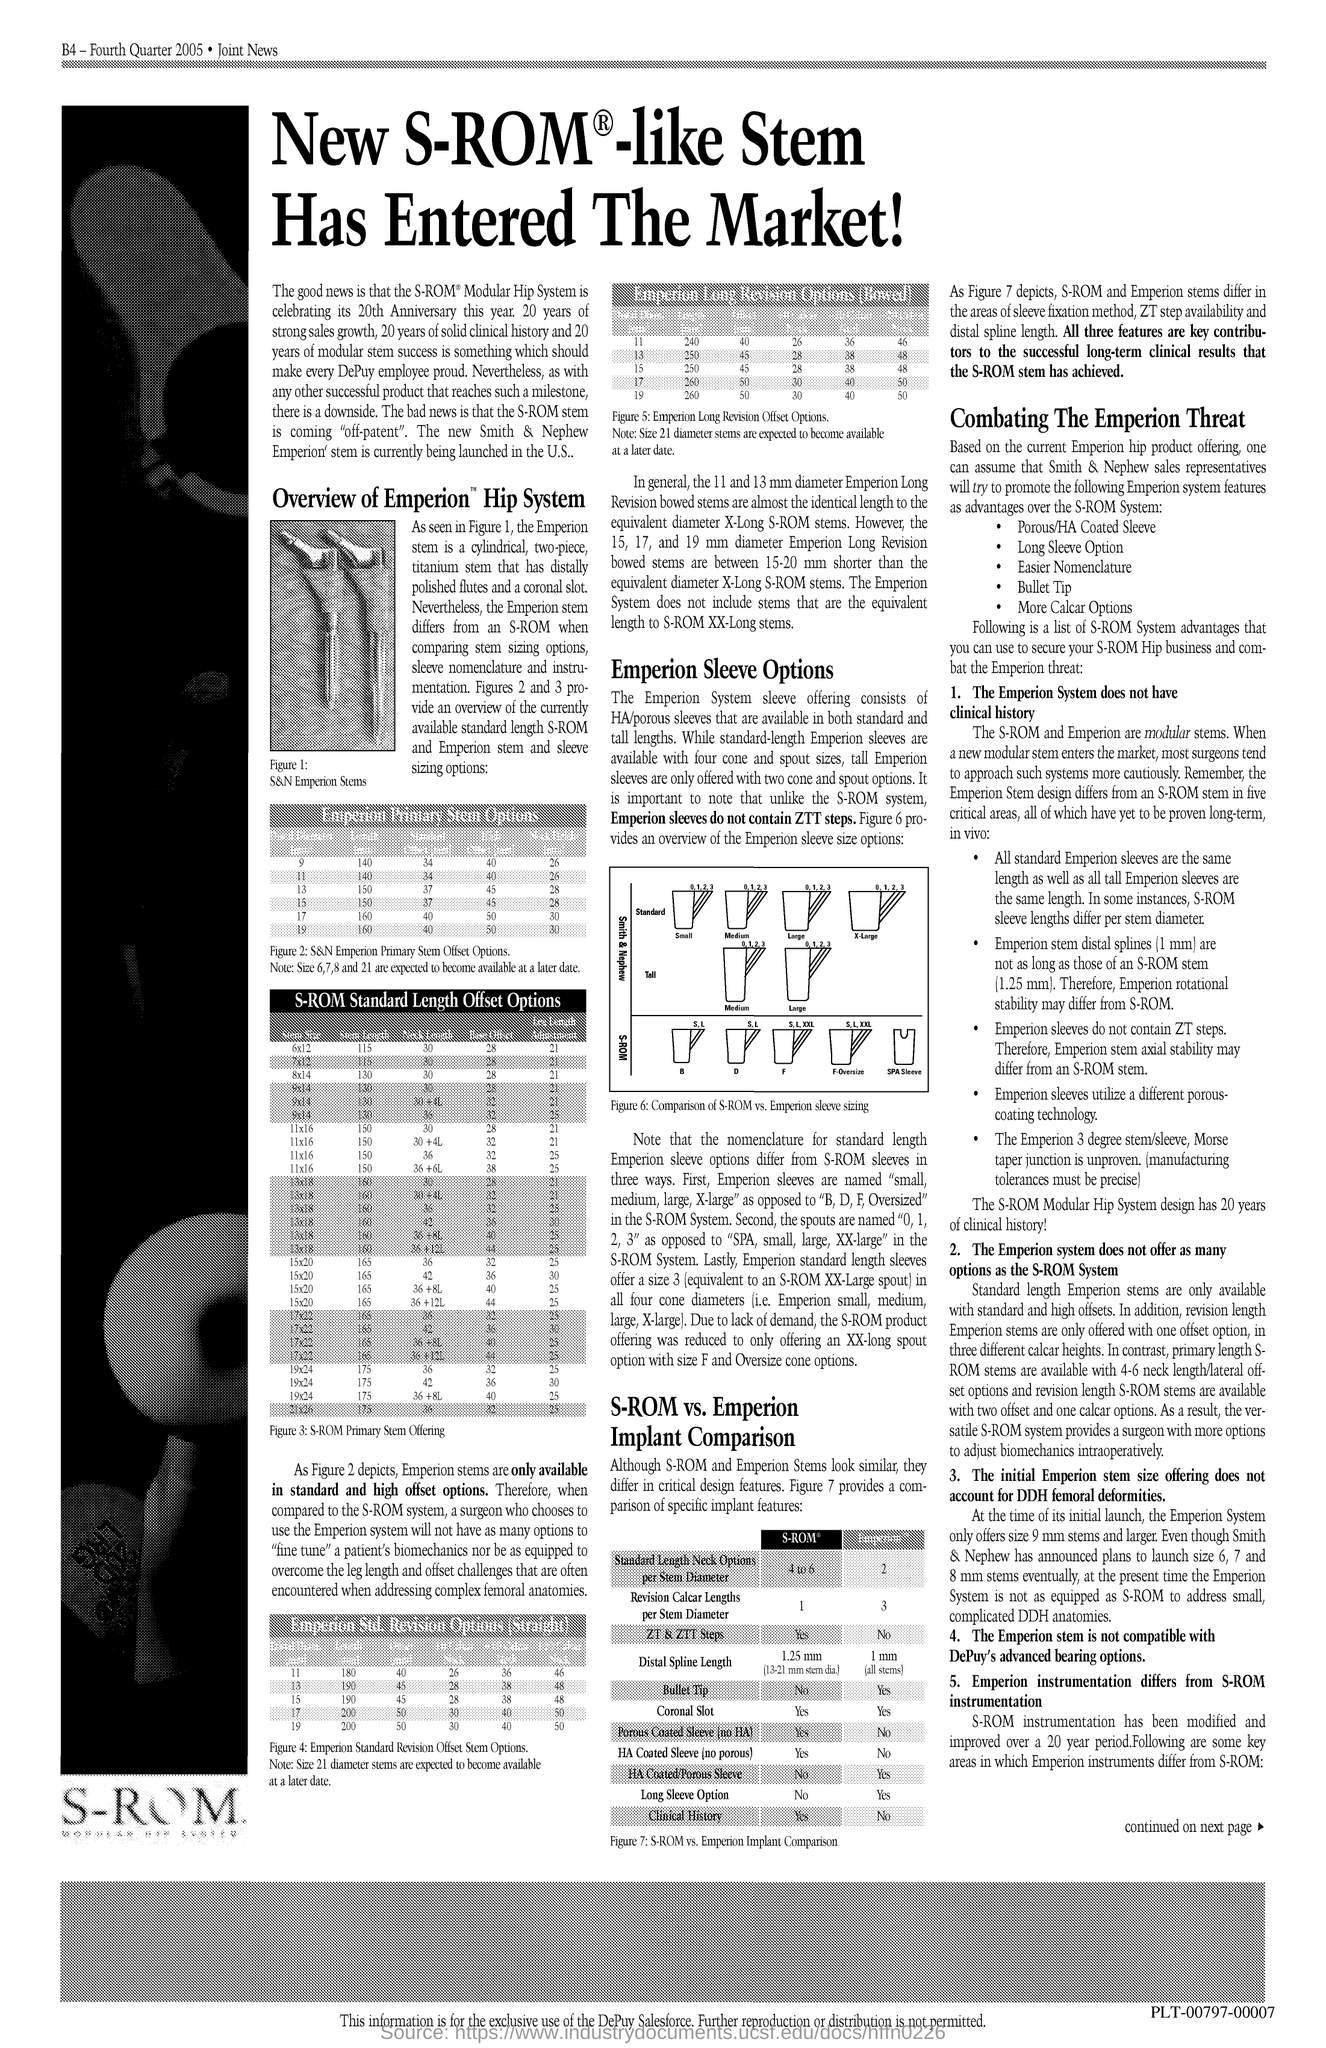What is the text written directly below the left side image?
Provide a succinct answer. S-ROM. 